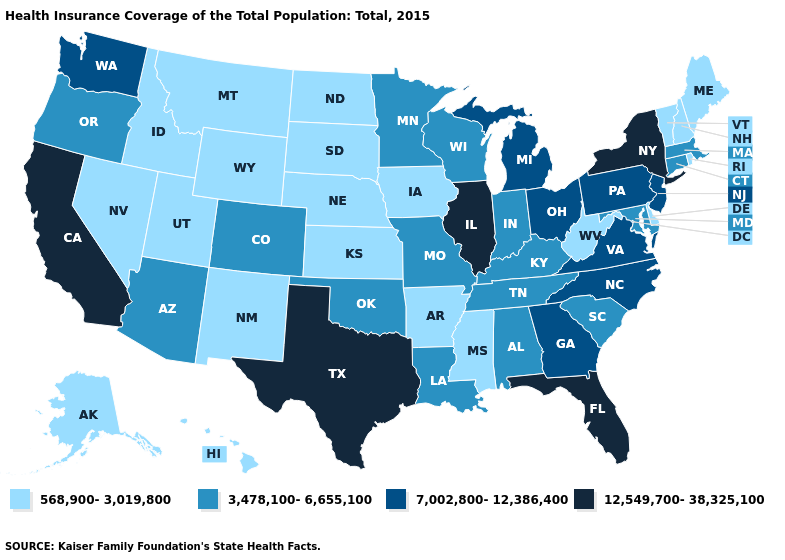Name the states that have a value in the range 3,478,100-6,655,100?
Write a very short answer. Alabama, Arizona, Colorado, Connecticut, Indiana, Kentucky, Louisiana, Maryland, Massachusetts, Minnesota, Missouri, Oklahoma, Oregon, South Carolina, Tennessee, Wisconsin. Which states have the lowest value in the MidWest?
Short answer required. Iowa, Kansas, Nebraska, North Dakota, South Dakota. Is the legend a continuous bar?
Write a very short answer. No. What is the value of Idaho?
Quick response, please. 568,900-3,019,800. Name the states that have a value in the range 7,002,800-12,386,400?
Quick response, please. Georgia, Michigan, New Jersey, North Carolina, Ohio, Pennsylvania, Virginia, Washington. Does Pennsylvania have the same value as North Carolina?
Keep it brief. Yes. Name the states that have a value in the range 7,002,800-12,386,400?
Short answer required. Georgia, Michigan, New Jersey, North Carolina, Ohio, Pennsylvania, Virginia, Washington. What is the value of Arizona?
Keep it brief. 3,478,100-6,655,100. How many symbols are there in the legend?
Be succinct. 4. What is the value of Massachusetts?
Concise answer only. 3,478,100-6,655,100. What is the highest value in states that border Ohio?
Short answer required. 7,002,800-12,386,400. What is the value of Georgia?
Be succinct. 7,002,800-12,386,400. Name the states that have a value in the range 7,002,800-12,386,400?
Be succinct. Georgia, Michigan, New Jersey, North Carolina, Ohio, Pennsylvania, Virginia, Washington. How many symbols are there in the legend?
Keep it brief. 4. What is the value of Montana?
Short answer required. 568,900-3,019,800. 